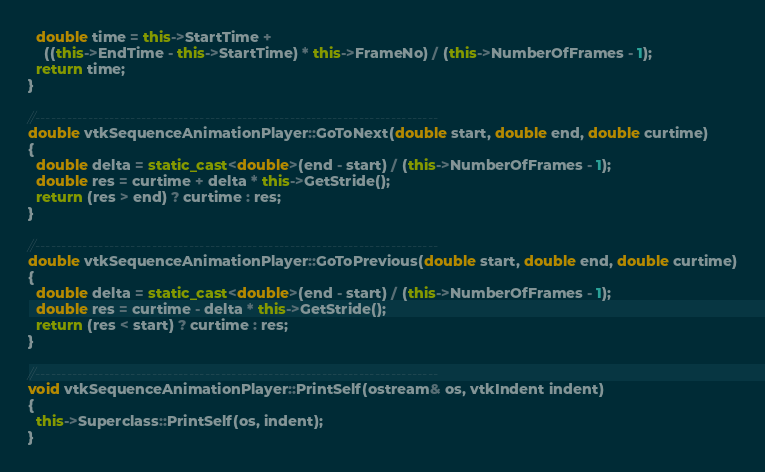Convert code to text. <code><loc_0><loc_0><loc_500><loc_500><_C++_>  double time = this->StartTime +
    ((this->EndTime - this->StartTime) * this->FrameNo) / (this->NumberOfFrames - 1);
  return time;
}

//----------------------------------------------------------------------------
double vtkSequenceAnimationPlayer::GoToNext(double start, double end, double curtime)
{
  double delta = static_cast<double>(end - start) / (this->NumberOfFrames - 1);
  double res = curtime + delta * this->GetStride();
  return (res > end) ? curtime : res;
}

//----------------------------------------------------------------------------
double vtkSequenceAnimationPlayer::GoToPrevious(double start, double end, double curtime)
{
  double delta = static_cast<double>(end - start) / (this->NumberOfFrames - 1);
  double res = curtime - delta * this->GetStride();
  return (res < start) ? curtime : res;
}

//----------------------------------------------------------------------------
void vtkSequenceAnimationPlayer::PrintSelf(ostream& os, vtkIndent indent)
{
  this->Superclass::PrintSelf(os, indent);
}
</code> 